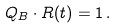Convert formula to latex. <formula><loc_0><loc_0><loc_500><loc_500>Q _ { B } \cdot R ( t ) = 1 \, .</formula> 